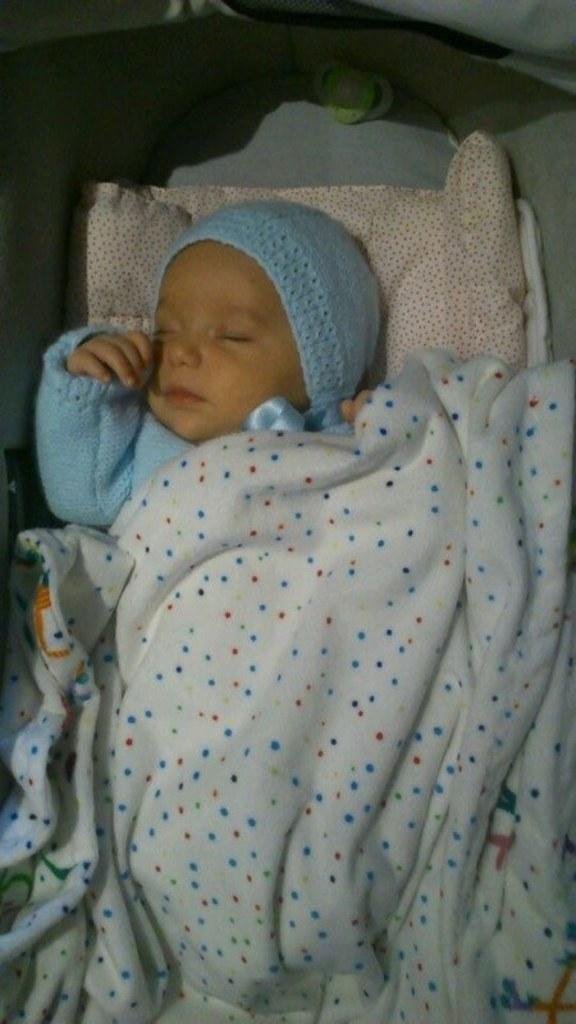What is the kid doing in the image? The kid is sleeping on a cloth on a bed. What else can be seen on the bed? There is an object on the bed. What is covering the kid? The kid has a cloth on them. What type of porter is carrying the snow in the image? There is no porter or snow present in the image. Where is the market located in the image? There is no market present in the image. 